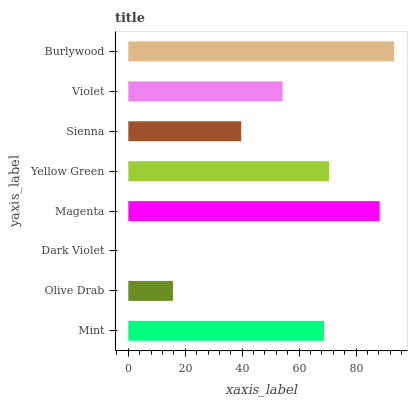Is Dark Violet the minimum?
Answer yes or no. Yes. Is Burlywood the maximum?
Answer yes or no. Yes. Is Olive Drab the minimum?
Answer yes or no. No. Is Olive Drab the maximum?
Answer yes or no. No. Is Mint greater than Olive Drab?
Answer yes or no. Yes. Is Olive Drab less than Mint?
Answer yes or no. Yes. Is Olive Drab greater than Mint?
Answer yes or no. No. Is Mint less than Olive Drab?
Answer yes or no. No. Is Mint the high median?
Answer yes or no. Yes. Is Violet the low median?
Answer yes or no. Yes. Is Violet the high median?
Answer yes or no. No. Is Burlywood the low median?
Answer yes or no. No. 